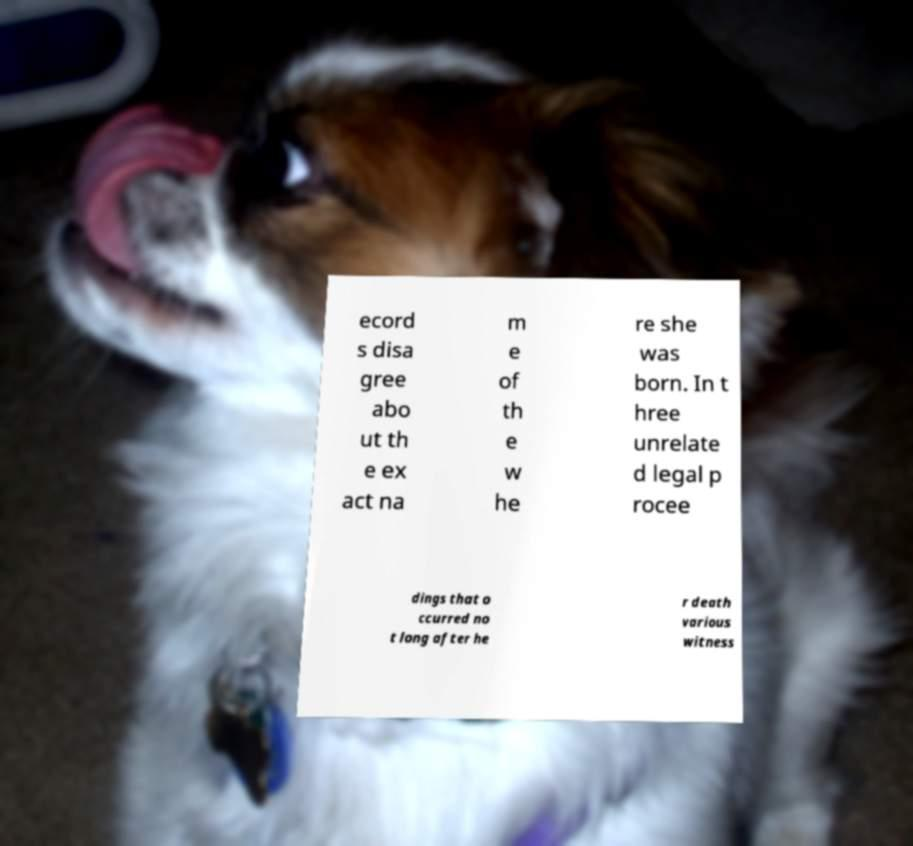I need the written content from this picture converted into text. Can you do that? ecord s disa gree abo ut th e ex act na m e of th e w he re she was born. In t hree unrelate d legal p rocee dings that o ccurred no t long after he r death various witness 